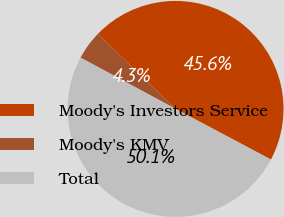<chart> <loc_0><loc_0><loc_500><loc_500><pie_chart><fcel>Moody's Investors Service<fcel>Moody's KMV<fcel>Total<nl><fcel>45.56%<fcel>4.33%<fcel>50.11%<nl></chart> 